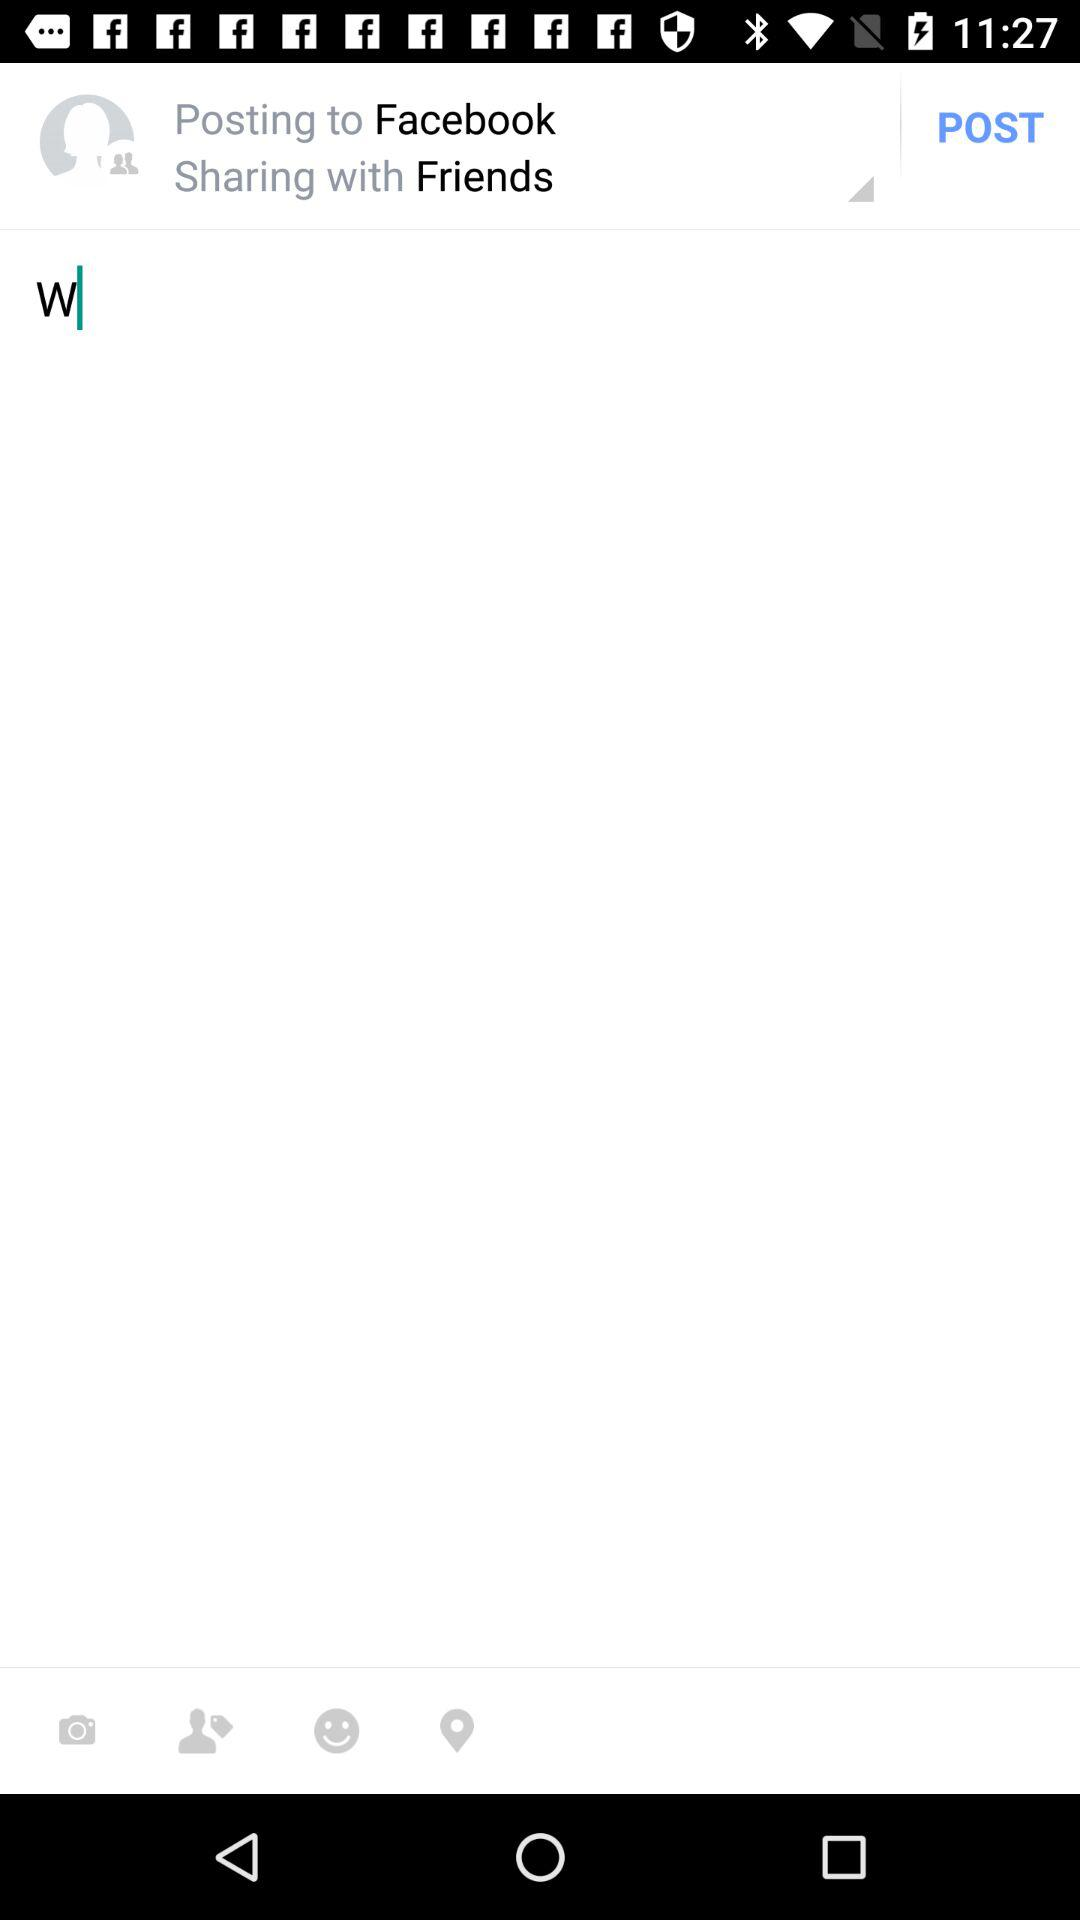Where are we posting? You are posting to "Facebook". 